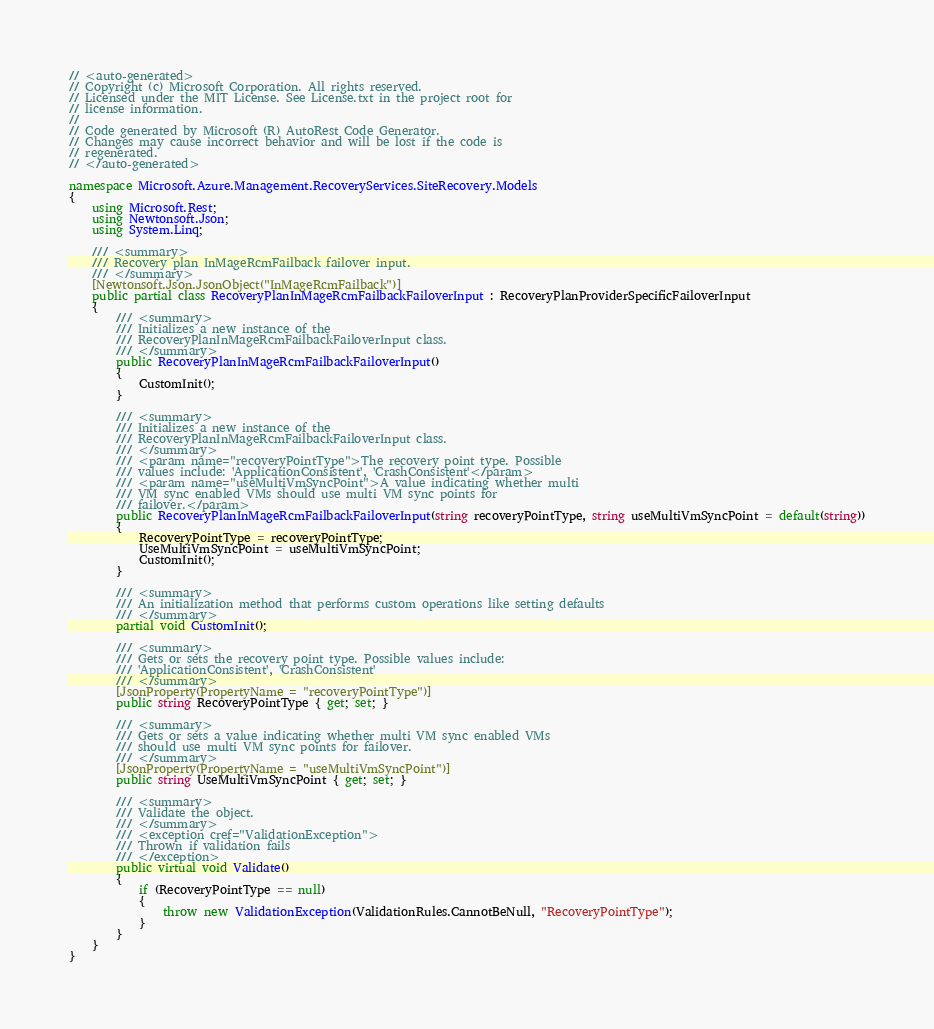Convert code to text. <code><loc_0><loc_0><loc_500><loc_500><_C#_>// <auto-generated>
// Copyright (c) Microsoft Corporation. All rights reserved.
// Licensed under the MIT License. See License.txt in the project root for
// license information.
//
// Code generated by Microsoft (R) AutoRest Code Generator.
// Changes may cause incorrect behavior and will be lost if the code is
// regenerated.
// </auto-generated>

namespace Microsoft.Azure.Management.RecoveryServices.SiteRecovery.Models
{
    using Microsoft.Rest;
    using Newtonsoft.Json;
    using System.Linq;

    /// <summary>
    /// Recovery plan InMageRcmFailback failover input.
    /// </summary>
    [Newtonsoft.Json.JsonObject("InMageRcmFailback")]
    public partial class RecoveryPlanInMageRcmFailbackFailoverInput : RecoveryPlanProviderSpecificFailoverInput
    {
        /// <summary>
        /// Initializes a new instance of the
        /// RecoveryPlanInMageRcmFailbackFailoverInput class.
        /// </summary>
        public RecoveryPlanInMageRcmFailbackFailoverInput()
        {
            CustomInit();
        }

        /// <summary>
        /// Initializes a new instance of the
        /// RecoveryPlanInMageRcmFailbackFailoverInput class.
        /// </summary>
        /// <param name="recoveryPointType">The recovery point type. Possible
        /// values include: 'ApplicationConsistent', 'CrashConsistent'</param>
        /// <param name="useMultiVmSyncPoint">A value indicating whether multi
        /// VM sync enabled VMs should use multi VM sync points for
        /// failover.</param>
        public RecoveryPlanInMageRcmFailbackFailoverInput(string recoveryPointType, string useMultiVmSyncPoint = default(string))
        {
            RecoveryPointType = recoveryPointType;
            UseMultiVmSyncPoint = useMultiVmSyncPoint;
            CustomInit();
        }

        /// <summary>
        /// An initialization method that performs custom operations like setting defaults
        /// </summary>
        partial void CustomInit();

        /// <summary>
        /// Gets or sets the recovery point type. Possible values include:
        /// 'ApplicationConsistent', 'CrashConsistent'
        /// </summary>
        [JsonProperty(PropertyName = "recoveryPointType")]
        public string RecoveryPointType { get; set; }

        /// <summary>
        /// Gets or sets a value indicating whether multi VM sync enabled VMs
        /// should use multi VM sync points for failover.
        /// </summary>
        [JsonProperty(PropertyName = "useMultiVmSyncPoint")]
        public string UseMultiVmSyncPoint { get; set; }

        /// <summary>
        /// Validate the object.
        /// </summary>
        /// <exception cref="ValidationException">
        /// Thrown if validation fails
        /// </exception>
        public virtual void Validate()
        {
            if (RecoveryPointType == null)
            {
                throw new ValidationException(ValidationRules.CannotBeNull, "RecoveryPointType");
            }
        }
    }
}
</code> 